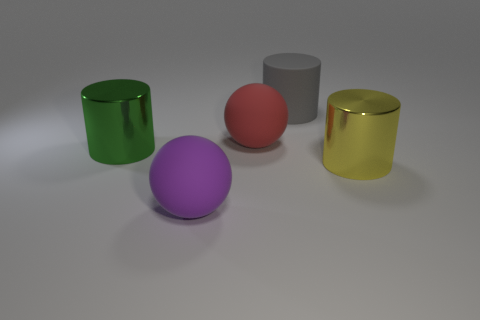Subtract all big green cylinders. How many cylinders are left? 2 Add 4 purple balls. How many objects exist? 9 Subtract 2 cylinders. How many cylinders are left? 1 Subtract all blue balls. Subtract all blue cylinders. How many balls are left? 2 Subtract all red cubes. How many green cylinders are left? 1 Subtract all big gray matte cylinders. Subtract all big red things. How many objects are left? 3 Add 3 purple spheres. How many purple spheres are left? 4 Add 1 brown metallic blocks. How many brown metallic blocks exist? 1 Subtract all gray cylinders. How many cylinders are left? 2 Subtract 0 brown cylinders. How many objects are left? 5 